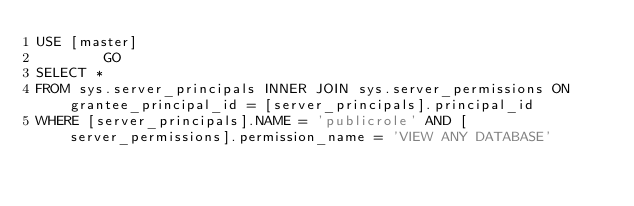Convert code to text. <code><loc_0><loc_0><loc_500><loc_500><_SQL_>USE [master]
        GO
SELECT *
FROM sys.server_principals INNER JOIN sys.server_permissions ON grantee_principal_id = [server_principals].principal_id
WHERE [server_principals].NAME = 'publicrole' AND [server_permissions].permission_name = 'VIEW ANY DATABASE'
</code> 